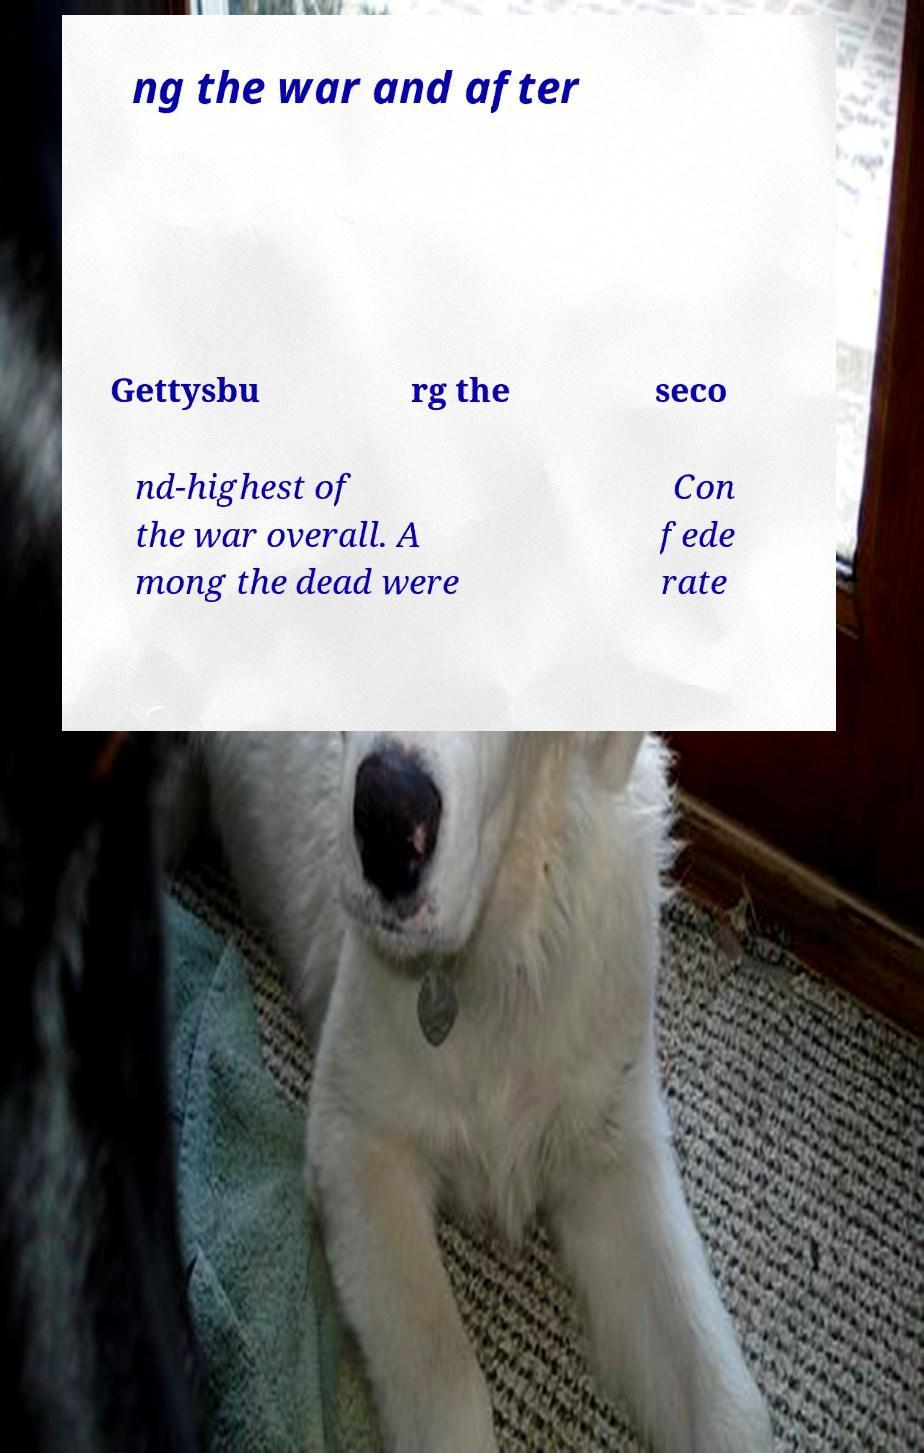Please identify and transcribe the text found in this image. ng the war and after Gettysbu rg the seco nd-highest of the war overall. A mong the dead were Con fede rate 